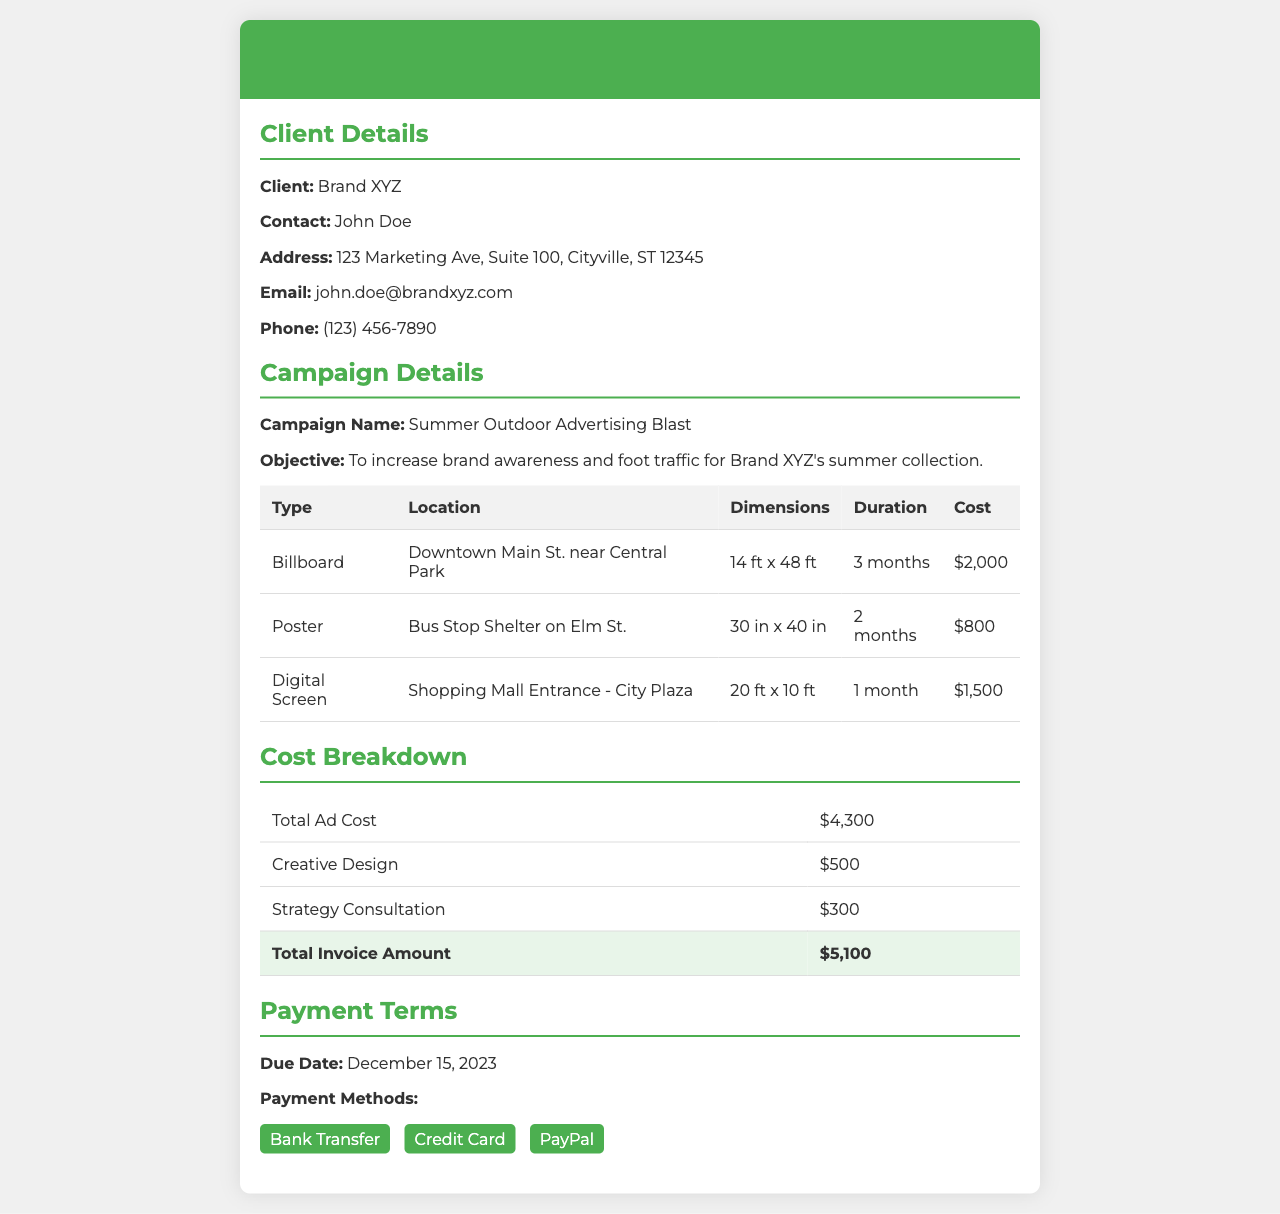What is the name of the campaign? The campaign name is stated in the "Campaign Details" section of the document, which is "Summer Outdoor Advertising Blast."
Answer: Summer Outdoor Advertising Blast Who is the client contact person? The contact person's name is provided in the "Client Details" section, which is John Doe.
Answer: John Doe What is the total invoice amount? The total invoice amount is listed in the "Cost Breakdown" section as $5,100.
Answer: $5,100 How long is the duration of the billboard advertisement? The duration for the billboard advertisement is mentioned in the "Campaign Details" table, which is 3 months.
Answer: 3 months What is the cost for creative design? The cost for creative design is included in the "Cost Breakdown" table as $500.
Answer: $500 Which payment method is NOT listed in the document? The document includes options for payment methods; therefore, any method not listed would answer this question. Examples could include checks or cash.
Answer: Checks What location is specified for the digital screen advertisement? The location for the digital screen is detailed in the "Campaign Details" table as "Shopping Mall Entrance - City Plaza."
Answer: Shopping Mall Entrance - City Plaza What is the due date for the payment? The due date for the payment is mentioned under "Payment Terms" as December 15, 2023.
Answer: December 15, 2023 How many types of advertisements are listed in the document? The count of advertisement types is determined from the "Campaign Details" table; there are three types listed: Billboard, Poster, and Digital Screen.
Answer: 3 